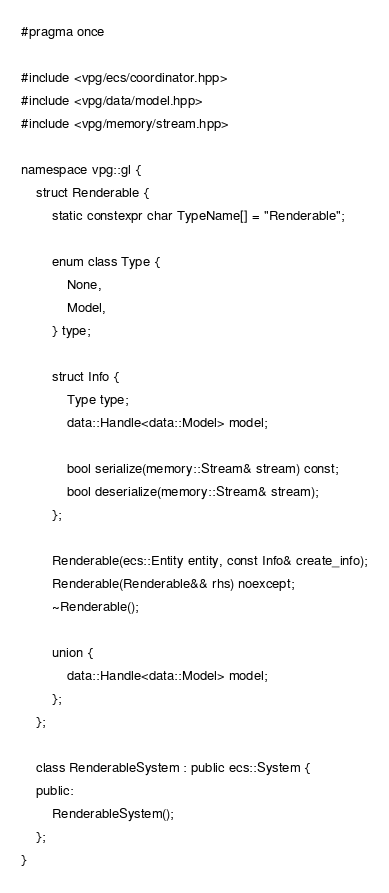Convert code to text. <code><loc_0><loc_0><loc_500><loc_500><_C++_>#pragma once

#include <vpg/ecs/coordinator.hpp>
#include <vpg/data/model.hpp>
#include <vpg/memory/stream.hpp>

namespace vpg::gl {
    struct Renderable {
        static constexpr char TypeName[] = "Renderable";

        enum class Type {
            None,
            Model,
        } type;

        struct Info {
            Type type;
            data::Handle<data::Model> model;

            bool serialize(memory::Stream& stream) const;
            bool deserialize(memory::Stream& stream);
        };

        Renderable(ecs::Entity entity, const Info& create_info);
        Renderable(Renderable&& rhs) noexcept;
        ~Renderable();

        union {
            data::Handle<data::Model> model;
        };
    };

    class RenderableSystem : public ecs::System {
    public:
        RenderableSystem();
    };
}</code> 